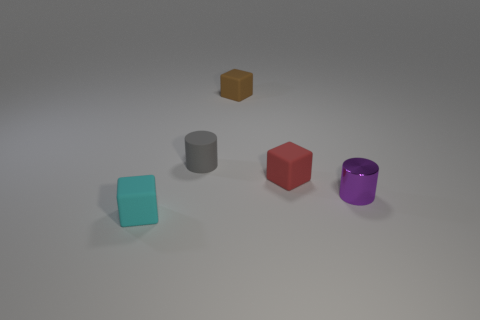Subtract all cyan cubes. How many cubes are left? 2 Add 1 small cylinders. How many objects exist? 6 Subtract all cubes. How many objects are left? 2 Subtract 1 cylinders. How many cylinders are left? 1 Subtract all green metal cylinders. Subtract all tiny brown blocks. How many objects are left? 4 Add 2 red rubber things. How many red rubber things are left? 3 Add 5 large green matte balls. How many large green matte balls exist? 5 Subtract 0 brown cylinders. How many objects are left? 5 Subtract all yellow cubes. Subtract all purple cylinders. How many cubes are left? 3 